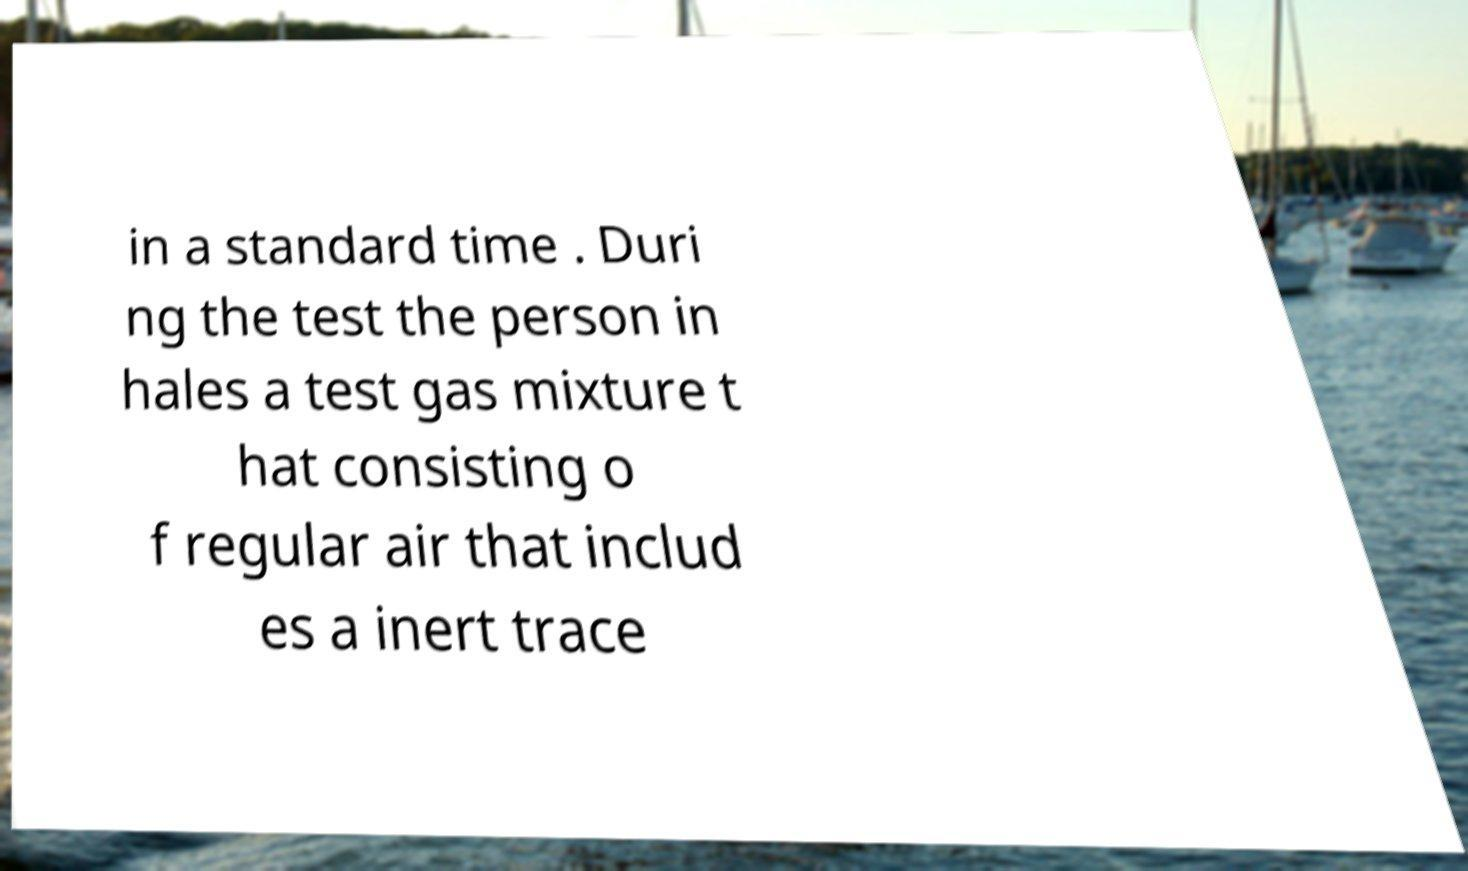What messages or text are displayed in this image? I need them in a readable, typed format. in a standard time . Duri ng the test the person in hales a test gas mixture t hat consisting o f regular air that includ es a inert trace 